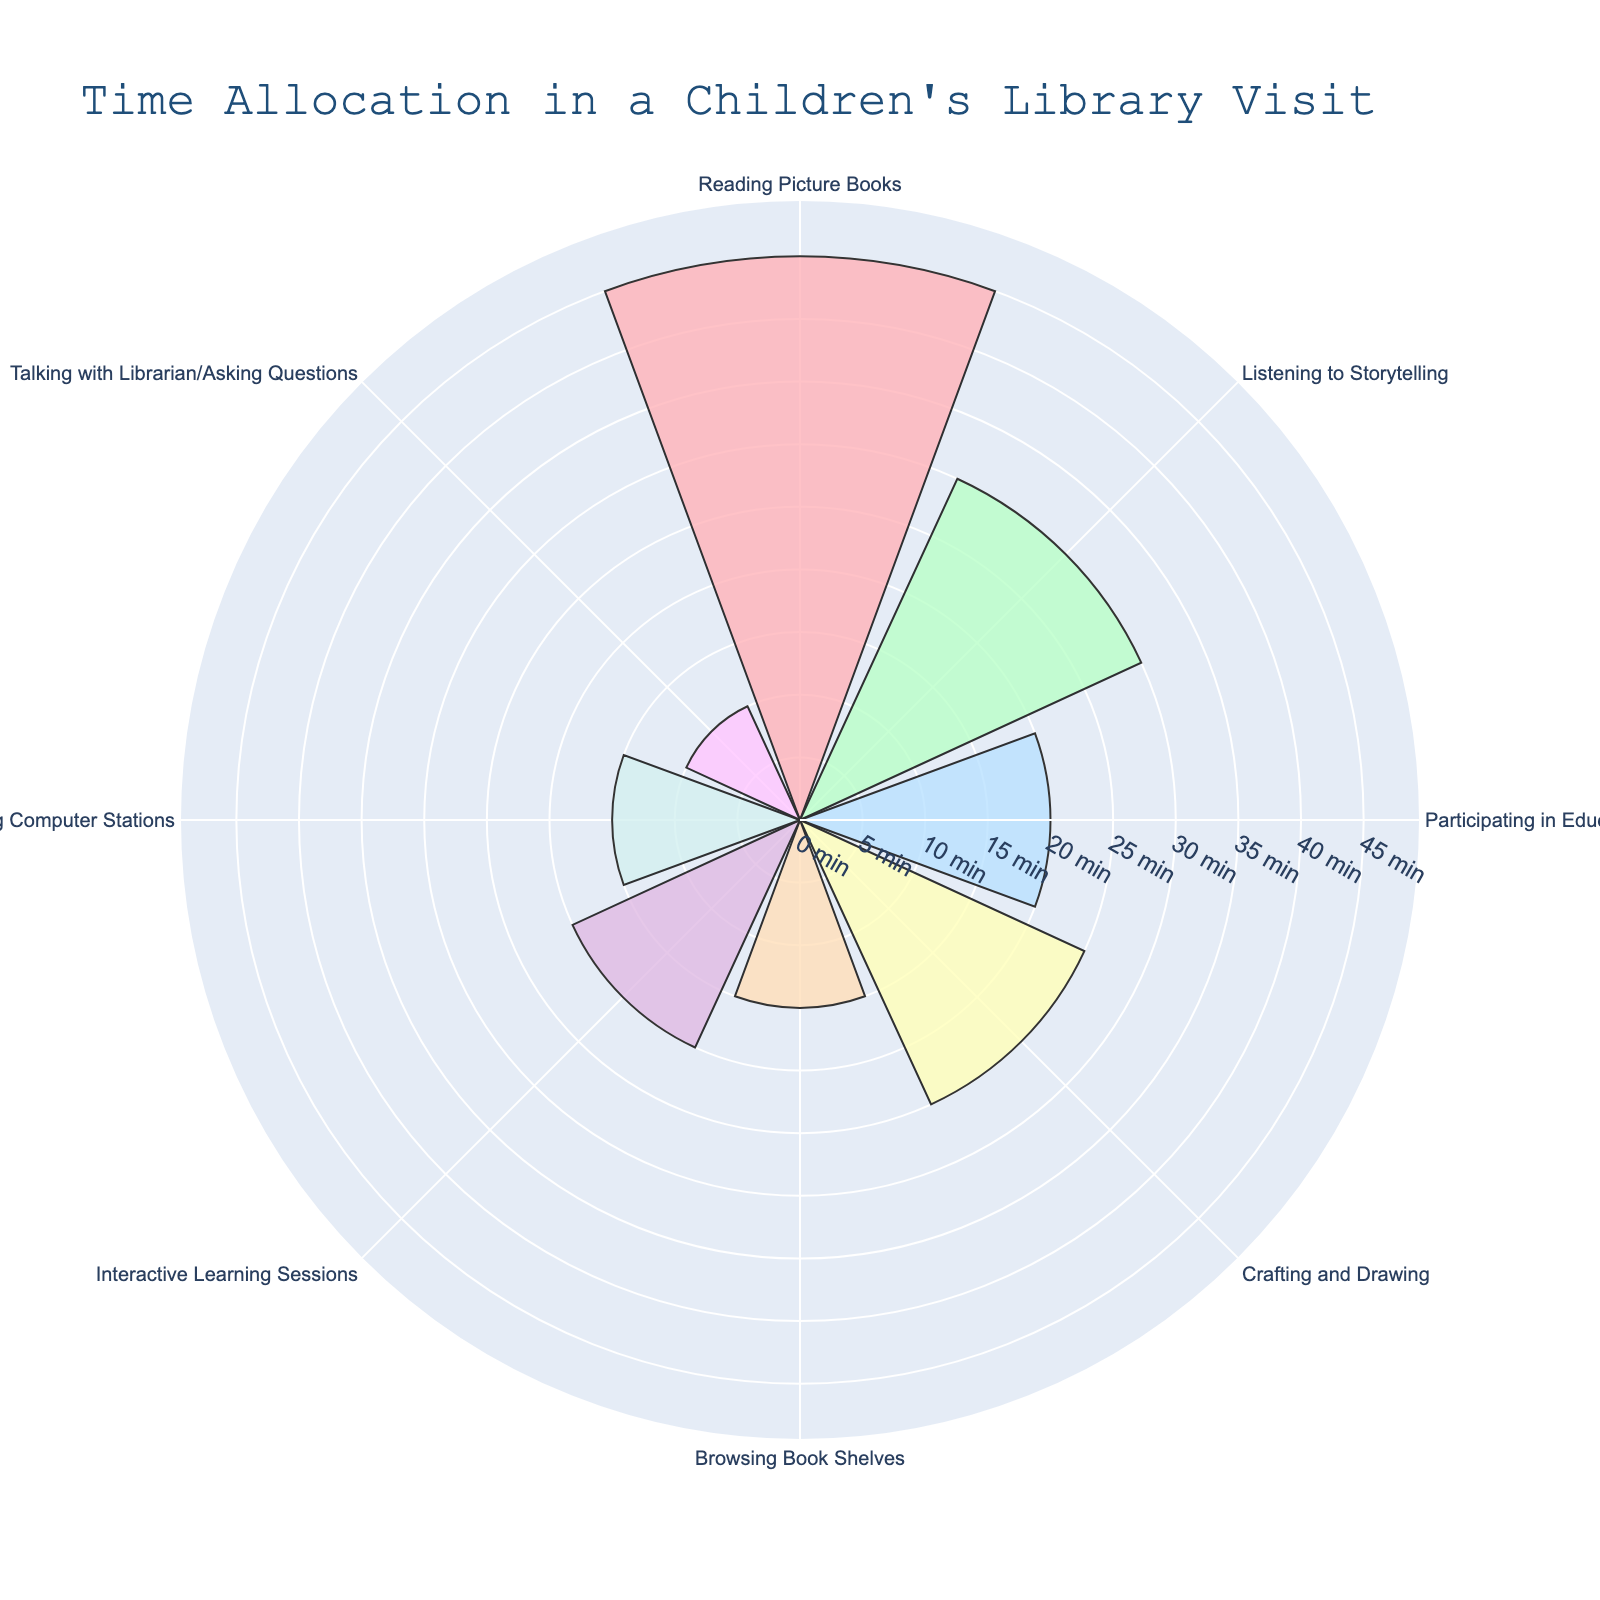What is the total time spent on participating in educational games? Locate the section labeled "Participating in Educational Games" and note the time allocated.
Answer: 20 Which activity has the longest time allocation? Identify the section with the longest bar or largest segment in the polar area chart.
Answer: Reading Picture Books How much more time is spent on crafting and drawing compared to browsing the book shelves? Find the time spent on "Crafting and Drawing" and "Browsing Book Shelves", then calculate the difference. 25 - 15 = 10 minutes more
Answer: 10 minutes What is the average time spent on all activities? Sum all the time allocations and divide by the number of activities. (45 + 30 + 20 + 25 + 15 + 20 + 15 + 10) / 8 = 22.5 minutes
Answer: 22.5 minutes How many activities last 15 minutes? Count the segments in the chart with a time allocation of 15 minutes.
Answer: 2 Is the time spent on using computer stations equal to the time spent on talking with the librarian/asking questions? Compare the time allocations for "Using Computer Stations" and "Talking with Librarian/Asking Questions".
Answer: No What fraction of the total time is spent on interactive learning sessions? Calculate the total time spent and find the fraction represented by "Interactive Learning Sessions". 180 (total time) 20/180 = 1/9
Answer: 1/9 Which two activities combined account for the same amount of time as reading picture books? Identify two segments whose combined times equal 45 minutes. 30 (Listening to Storytelling) + 15 (Browsing Book Shelves) = 45 minutes
Answer: Listening to Storytelling and Browsing Book Shelves Between crafting and drawing and using computer stations, which activity do children spend more time on and by how much? Compare the time spent on "Crafting and Drawing" and "Using Computer Stations" and find the difference. 25 - 15 = 10 minutes more
Answer: Crafting and Drawing, 10 minutes What is the smallest time allocation and which activity does it correspond to? Identify the shortest segment in the chart and note the corresponding activity and time.
Answer: Talking with Librarian/Asking Questions, 10 minutes 